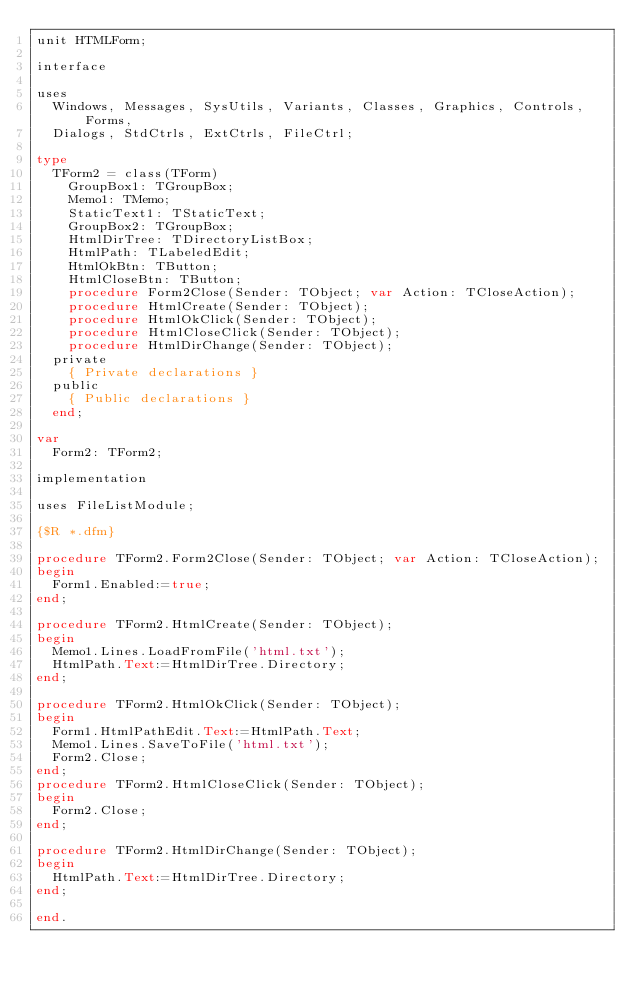Convert code to text. <code><loc_0><loc_0><loc_500><loc_500><_Pascal_>unit HTMLForm;

interface

uses
  Windows, Messages, SysUtils, Variants, Classes, Graphics, Controls, Forms,
  Dialogs, StdCtrls, ExtCtrls, FileCtrl;

type
  TForm2 = class(TForm)
    GroupBox1: TGroupBox;
    Memo1: TMemo;
    StaticText1: TStaticText;
    GroupBox2: TGroupBox;
    HtmlDirTree: TDirectoryListBox;
    HtmlPath: TLabeledEdit;
    HtmlOkBtn: TButton;
    HtmlCloseBtn: TButton;
    procedure Form2Close(Sender: TObject; var Action: TCloseAction);
    procedure HtmlCreate(Sender: TObject);
    procedure HtmlOkClick(Sender: TObject);
    procedure HtmlCloseClick(Sender: TObject);
    procedure HtmlDirChange(Sender: TObject);
  private
    { Private declarations }
  public
    { Public declarations }
  end;

var
  Form2: TForm2;

implementation

uses FileListModule;

{$R *.dfm}

procedure TForm2.Form2Close(Sender: TObject; var Action: TCloseAction);
begin
  Form1.Enabled:=true;
end;

procedure TForm2.HtmlCreate(Sender: TObject);
begin
  Memo1.Lines.LoadFromFile('html.txt');
  HtmlPath.Text:=HtmlDirTree.Directory;
end;

procedure TForm2.HtmlOkClick(Sender: TObject);
begin
  Form1.HtmlPathEdit.Text:=HtmlPath.Text;
  Memo1.Lines.SaveToFile('html.txt');
  Form2.Close;
end;
procedure TForm2.HtmlCloseClick(Sender: TObject);
begin
  Form2.Close;
end;

procedure TForm2.HtmlDirChange(Sender: TObject);
begin
  HtmlPath.Text:=HtmlDirTree.Directory;
end;

end.
</code> 